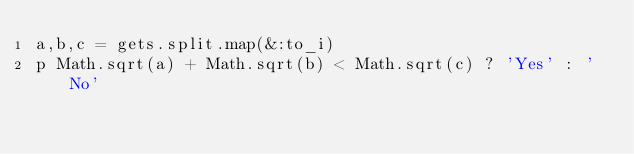<code> <loc_0><loc_0><loc_500><loc_500><_Ruby_>a,b,c = gets.split.map(&:to_i)
p Math.sqrt(a) + Math.sqrt(b) < Math.sqrt(c) ? 'Yes' : 'No'</code> 